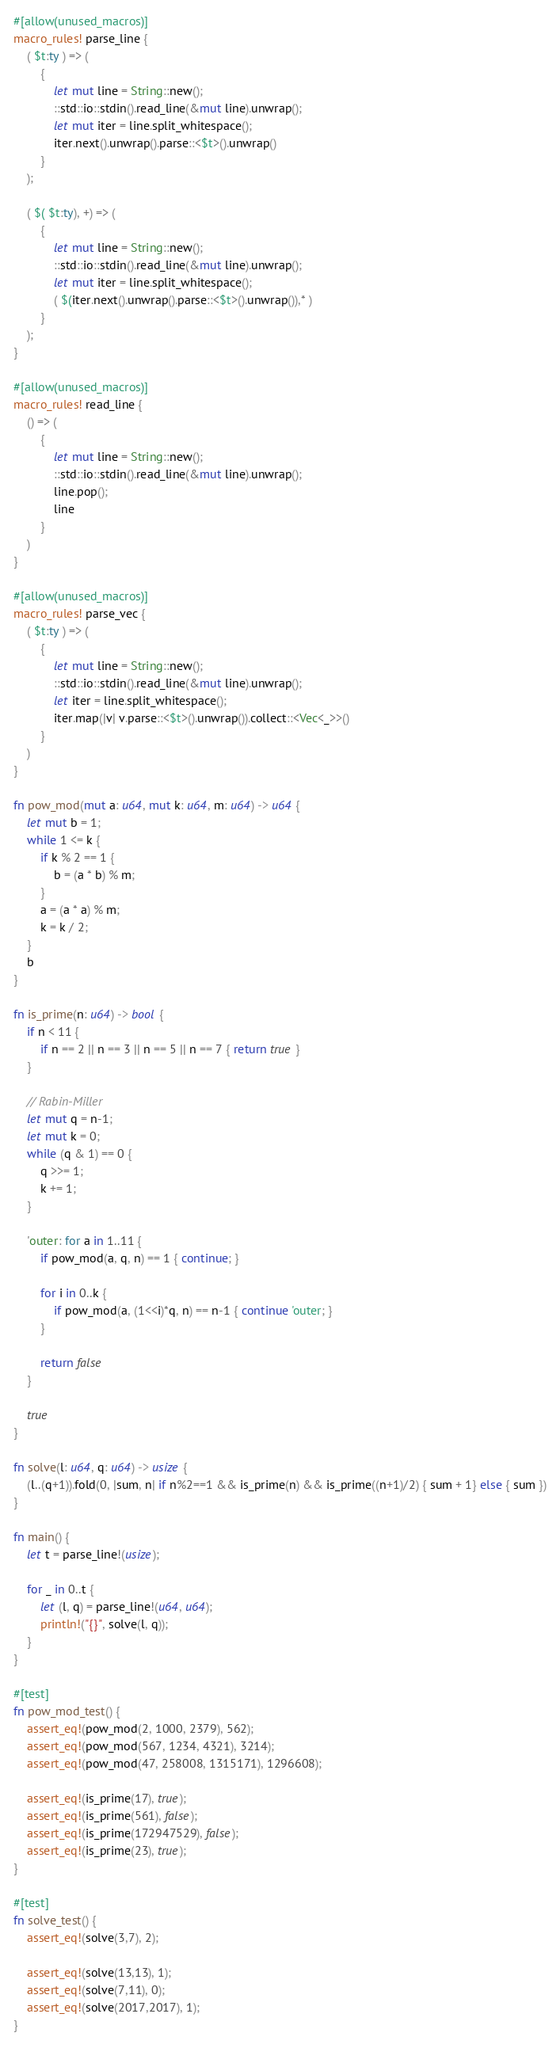Convert code to text. <code><loc_0><loc_0><loc_500><loc_500><_Rust_>#[allow(unused_macros)]
macro_rules! parse_line {
    ( $t:ty ) => (
        {
            let mut line = String::new();
            ::std::io::stdin().read_line(&mut line).unwrap();
            let mut iter = line.split_whitespace();
            iter.next().unwrap().parse::<$t>().unwrap()
        }
    );

    ( $( $t:ty), +) => (
        {
            let mut line = String::new();
            ::std::io::stdin().read_line(&mut line).unwrap();
            let mut iter = line.split_whitespace();
            ( $(iter.next().unwrap().parse::<$t>().unwrap()),* )
        }
    );
}

#[allow(unused_macros)]
macro_rules! read_line {
    () => (
        {
            let mut line = String::new();
            ::std::io::stdin().read_line(&mut line).unwrap();
            line.pop();
            line
        }
    )
}

#[allow(unused_macros)]
macro_rules! parse_vec {
    ( $t:ty ) => (
        {
            let mut line = String::new();
            ::std::io::stdin().read_line(&mut line).unwrap();
            let iter = line.split_whitespace();
            iter.map(|v| v.parse::<$t>().unwrap()).collect::<Vec<_>>()
        }
    )
}

fn pow_mod(mut a: u64, mut k: u64, m: u64) -> u64 {
    let mut b = 1;
    while 1 <= k {
        if k % 2 == 1 {
            b = (a * b) % m;
        }
        a = (a * a) % m;
        k = k / 2;
    }
    b
}

fn is_prime(n: u64) -> bool {
    if n < 11 {
        if n == 2 || n == 3 || n == 5 || n == 7 { return true }
    }

    // Rabin-Miller
    let mut q = n-1;
    let mut k = 0;
    while (q & 1) == 0 {
        q >>= 1;
        k += 1;
    }

    'outer: for a in 1..11 {
        if pow_mod(a, q, n) == 1 { continue; }

        for i in 0..k {
            if pow_mod(a, (1<<i)*q, n) == n-1 { continue 'outer; }
        }

        return false
    }

    true
}

fn solve(l: u64, q: u64) -> usize {
    (l..(q+1)).fold(0, |sum, n| if n%2==1 && is_prime(n) && is_prime((n+1)/2) { sum + 1} else { sum })
}

fn main() {
    let t = parse_line!(usize);

    for _ in 0..t {
        let (l, q) = parse_line!(u64, u64);
        println!("{}", solve(l, q));
    }
}

#[test]
fn pow_mod_test() {
    assert_eq!(pow_mod(2, 1000, 2379), 562);
    assert_eq!(pow_mod(567, 1234, 4321), 3214);
    assert_eq!(pow_mod(47, 258008, 1315171), 1296608);

    assert_eq!(is_prime(17), true);
    assert_eq!(is_prime(561), false);
    assert_eq!(is_prime(172947529), false);
    assert_eq!(is_prime(23), true);
}

#[test]
fn solve_test() {
    assert_eq!(solve(3,7), 2);

    assert_eq!(solve(13,13), 1);
    assert_eq!(solve(7,11), 0);
    assert_eq!(solve(2017,2017), 1);
}
</code> 